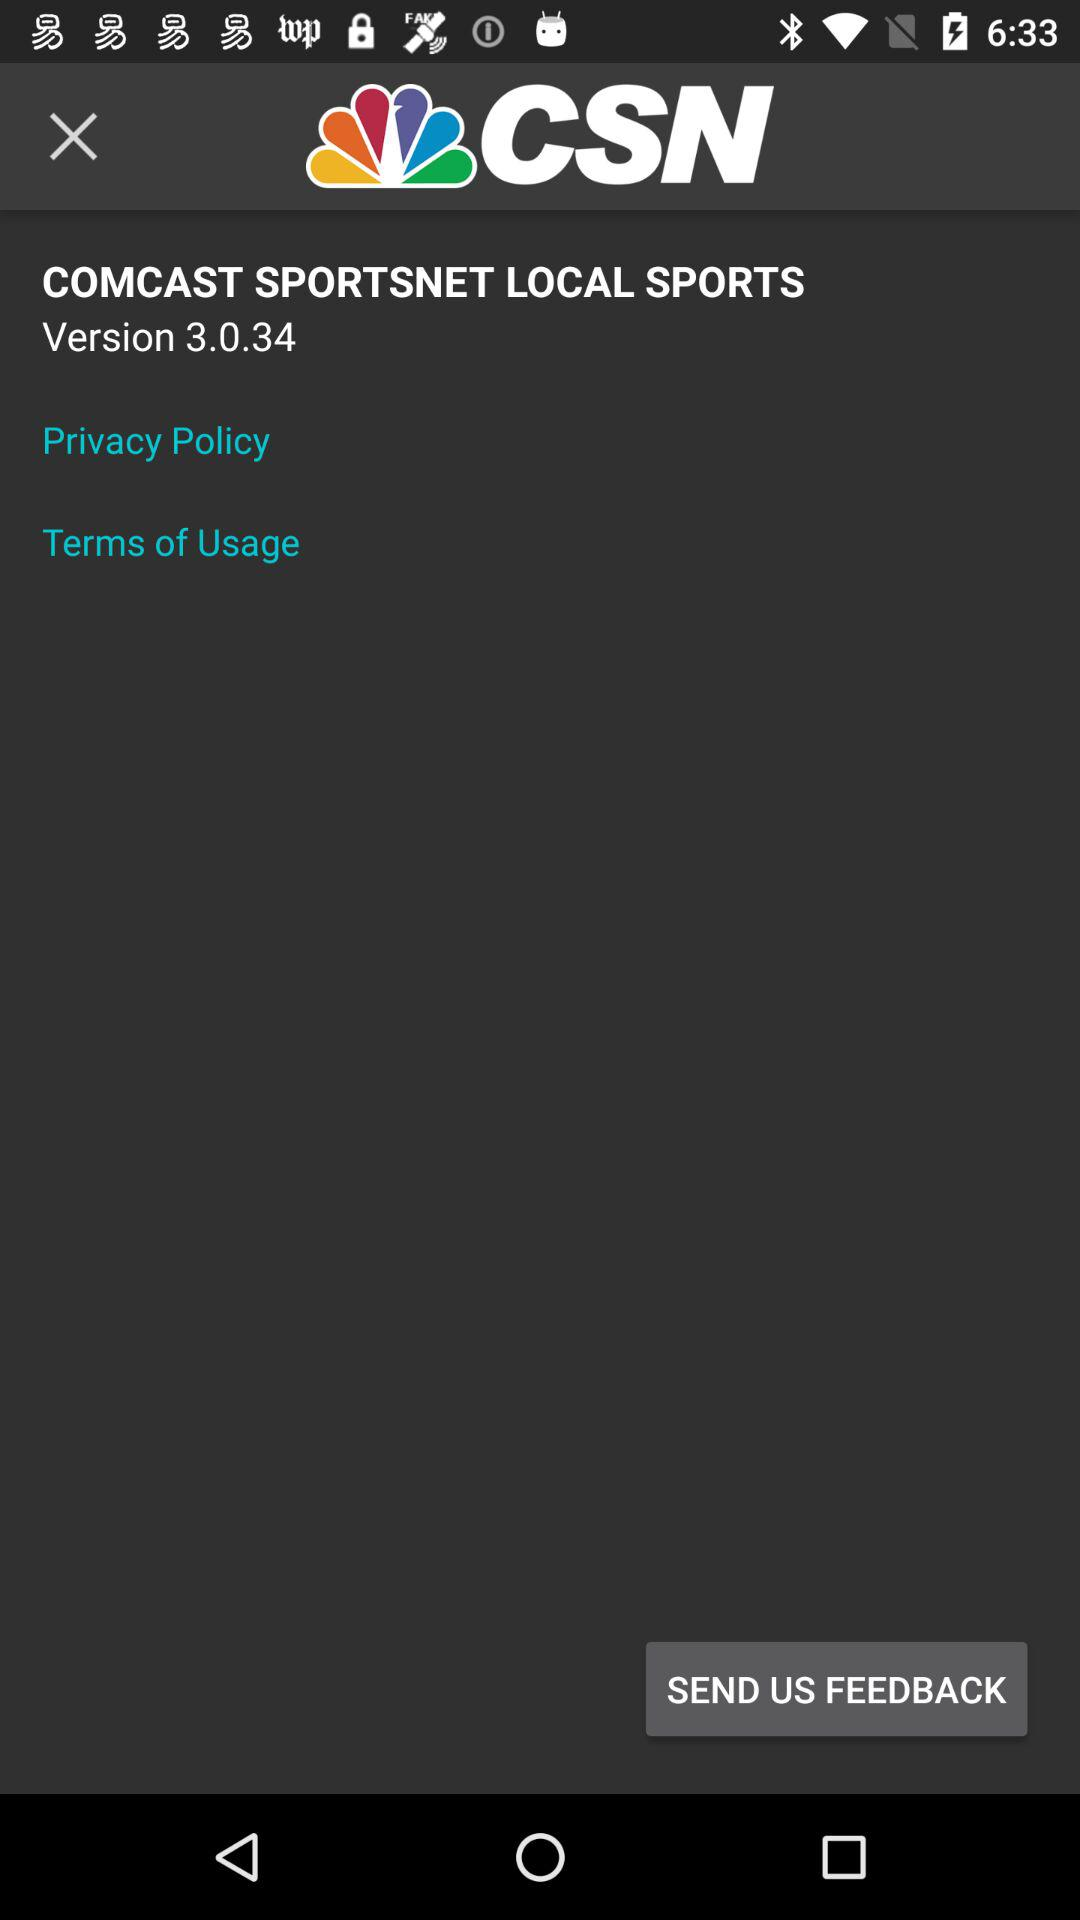What is the application name? The application name is "COMCAST SPORTSNET LOCAL SPORTS". 